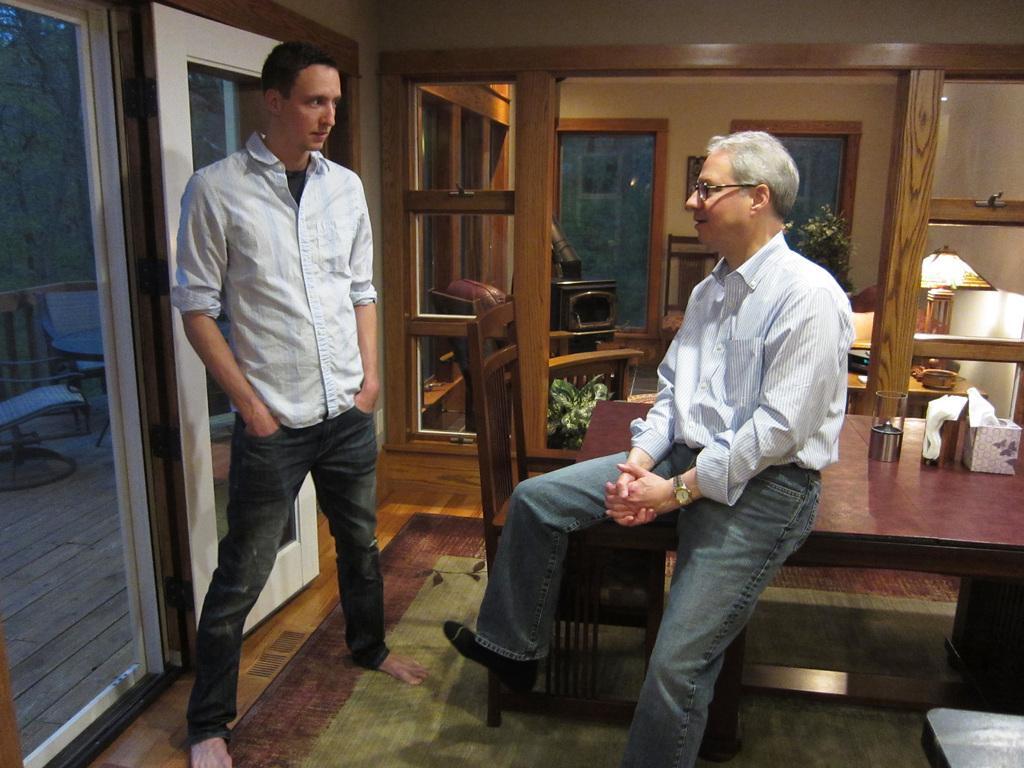In one or two sentences, can you explain what this image depicts? In this picture this person standing. This person sitting on the table. We can see chair and table. On the table we can see tissue, glass. On the background we can see wall,glass window,plant,lamp. From this class we can see chair,table and trees. This is floor 